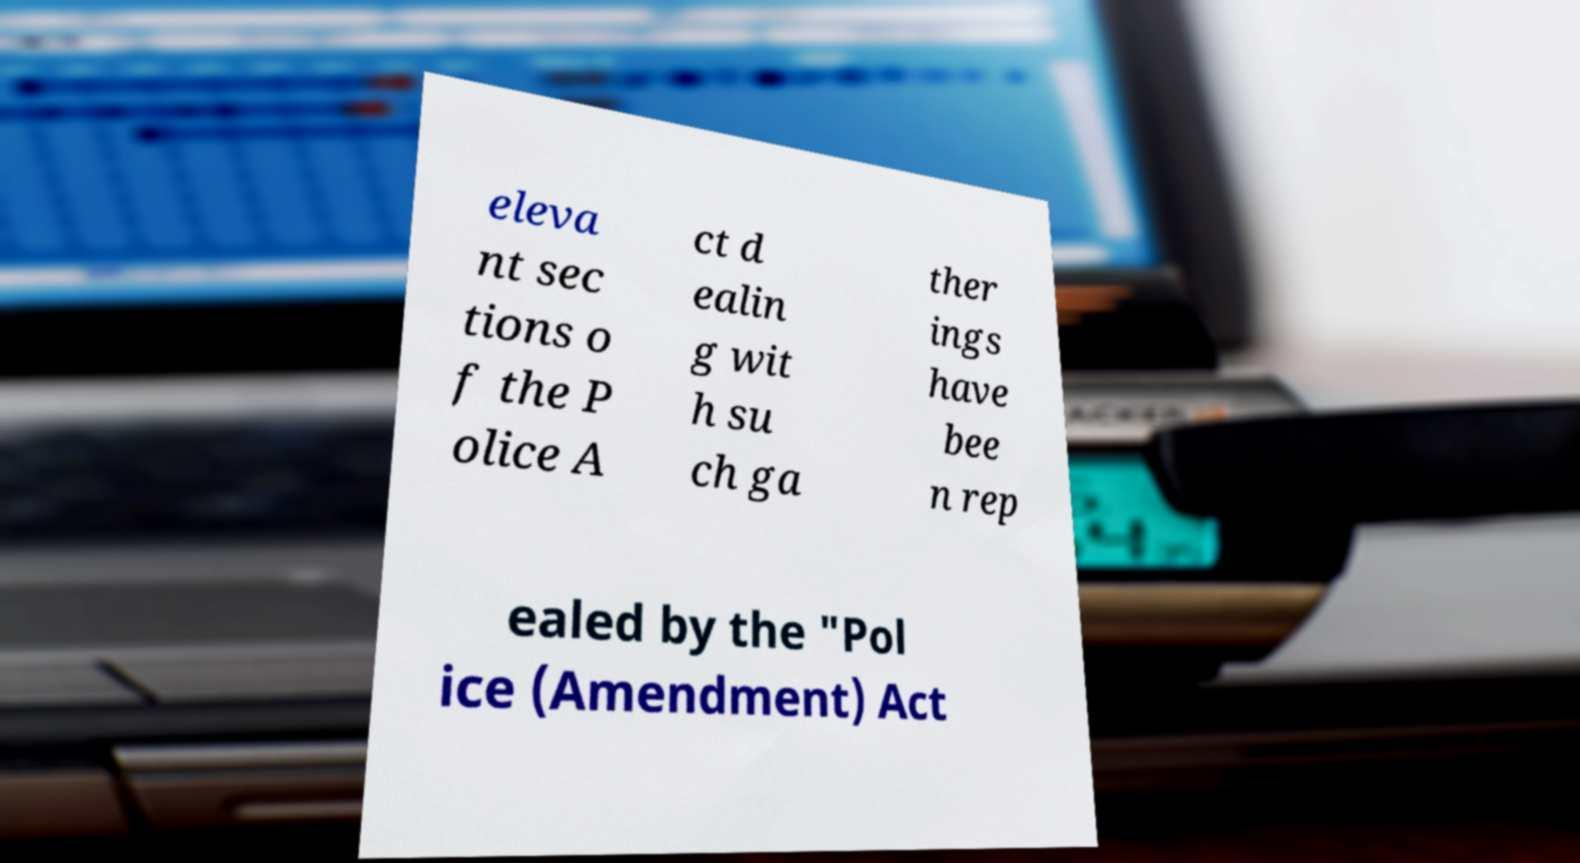Can you read and provide the text displayed in the image?This photo seems to have some interesting text. Can you extract and type it out for me? eleva nt sec tions o f the P olice A ct d ealin g wit h su ch ga ther ings have bee n rep ealed by the "Pol ice (Amendment) Act 